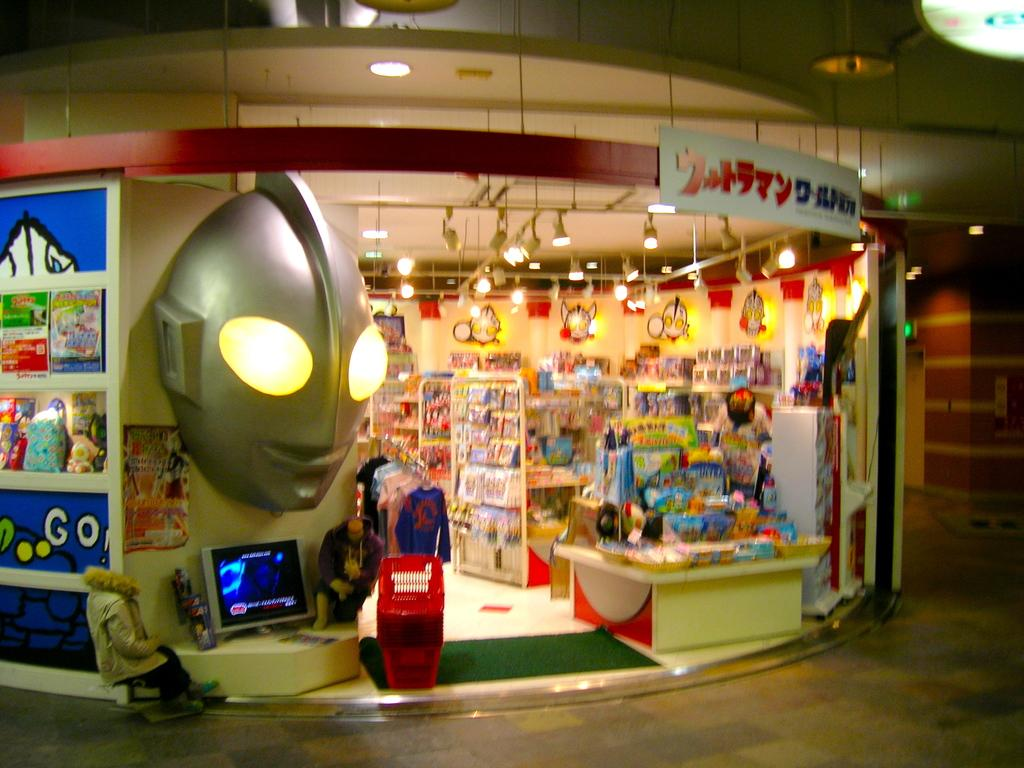<image>
Create a compact narrative representing the image presented. A toy store with a banner saying go on the left side of the store. 